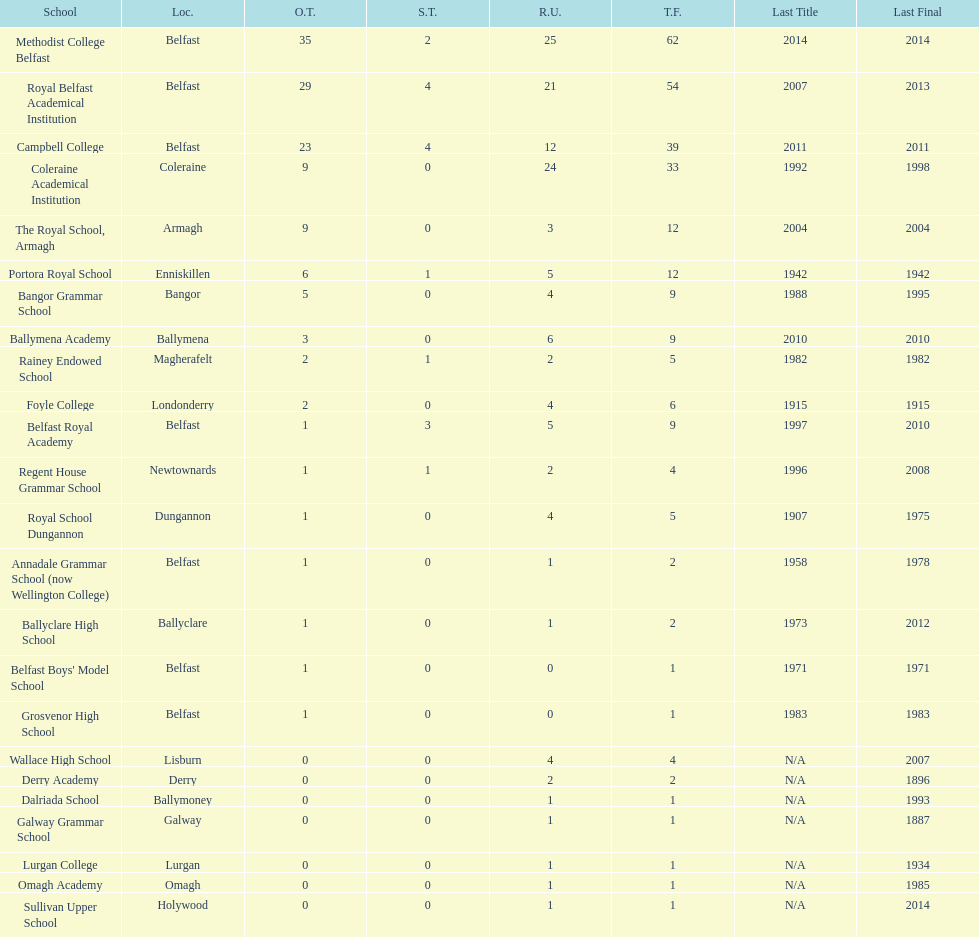What was the last year that the regent house grammar school won a title? 1996. Can you give me this table as a dict? {'header': ['School', 'Loc.', 'O.T.', 'S.T.', 'R.U.', 'T.F.', 'Last Title', 'Last Final'], 'rows': [['Methodist College Belfast', 'Belfast', '35', '2', '25', '62', '2014', '2014'], ['Royal Belfast Academical Institution', 'Belfast', '29', '4', '21', '54', '2007', '2013'], ['Campbell College', 'Belfast', '23', '4', '12', '39', '2011', '2011'], ['Coleraine Academical Institution', 'Coleraine', '9', '0', '24', '33', '1992', '1998'], ['The Royal School, Armagh', 'Armagh', '9', '0', '3', '12', '2004', '2004'], ['Portora Royal School', 'Enniskillen', '6', '1', '5', '12', '1942', '1942'], ['Bangor Grammar School', 'Bangor', '5', '0', '4', '9', '1988', '1995'], ['Ballymena Academy', 'Ballymena', '3', '0', '6', '9', '2010', '2010'], ['Rainey Endowed School', 'Magherafelt', '2', '1', '2', '5', '1982', '1982'], ['Foyle College', 'Londonderry', '2', '0', '4', '6', '1915', '1915'], ['Belfast Royal Academy', 'Belfast', '1', '3', '5', '9', '1997', '2010'], ['Regent House Grammar School', 'Newtownards', '1', '1', '2', '4', '1996', '2008'], ['Royal School Dungannon', 'Dungannon', '1', '0', '4', '5', '1907', '1975'], ['Annadale Grammar School (now Wellington College)', 'Belfast', '1', '0', '1', '2', '1958', '1978'], ['Ballyclare High School', 'Ballyclare', '1', '0', '1', '2', '1973', '2012'], ["Belfast Boys' Model School", 'Belfast', '1', '0', '0', '1', '1971', '1971'], ['Grosvenor High School', 'Belfast', '1', '0', '0', '1', '1983', '1983'], ['Wallace High School', 'Lisburn', '0', '0', '4', '4', 'N/A', '2007'], ['Derry Academy', 'Derry', '0', '0', '2', '2', 'N/A', '1896'], ['Dalriada School', 'Ballymoney', '0', '0', '1', '1', 'N/A', '1993'], ['Galway Grammar School', 'Galway', '0', '0', '1', '1', 'N/A', '1887'], ['Lurgan College', 'Lurgan', '0', '0', '1', '1', 'N/A', '1934'], ['Omagh Academy', 'Omagh', '0', '0', '1', '1', 'N/A', '1985'], ['Sullivan Upper School', 'Holywood', '0', '0', '1', '1', 'N/A', '2014']]} 